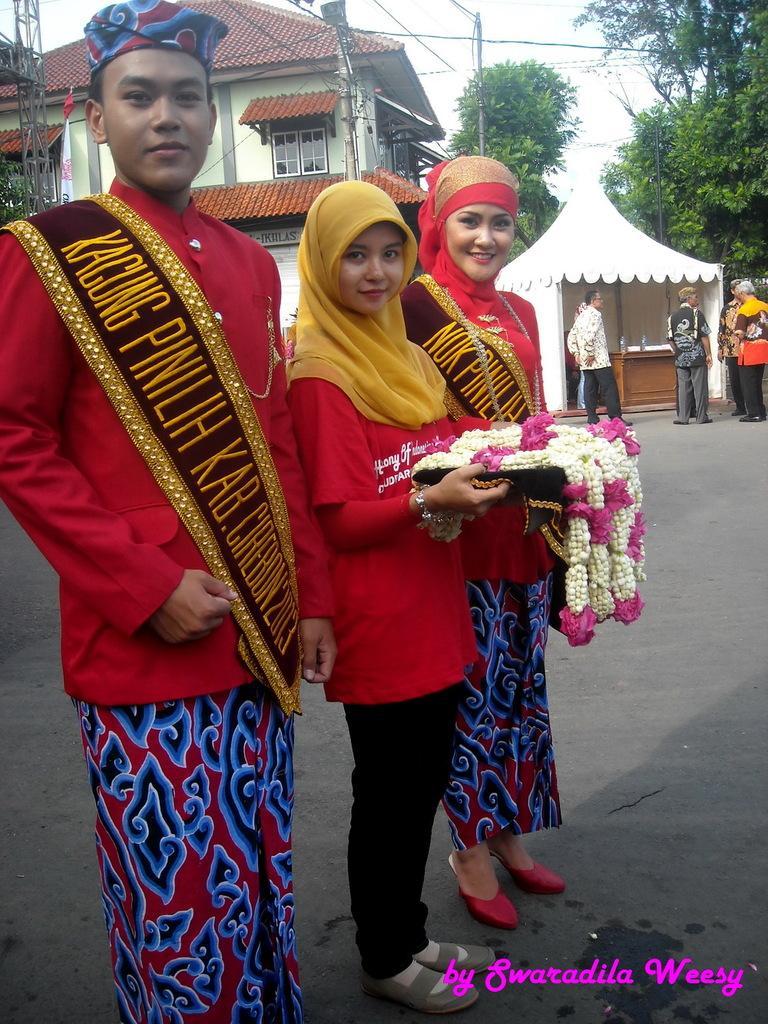In one or two sentences, can you explain what this image depicts? In this image I can see on the left side a man is standing, he is wearing the red color coat. Beside him two girls are standing, they are holding the garlands. At the back side there are trees and buildings, on the right side it looks like a tent, Few people are standing. In the right hand side bottom there is the name. 